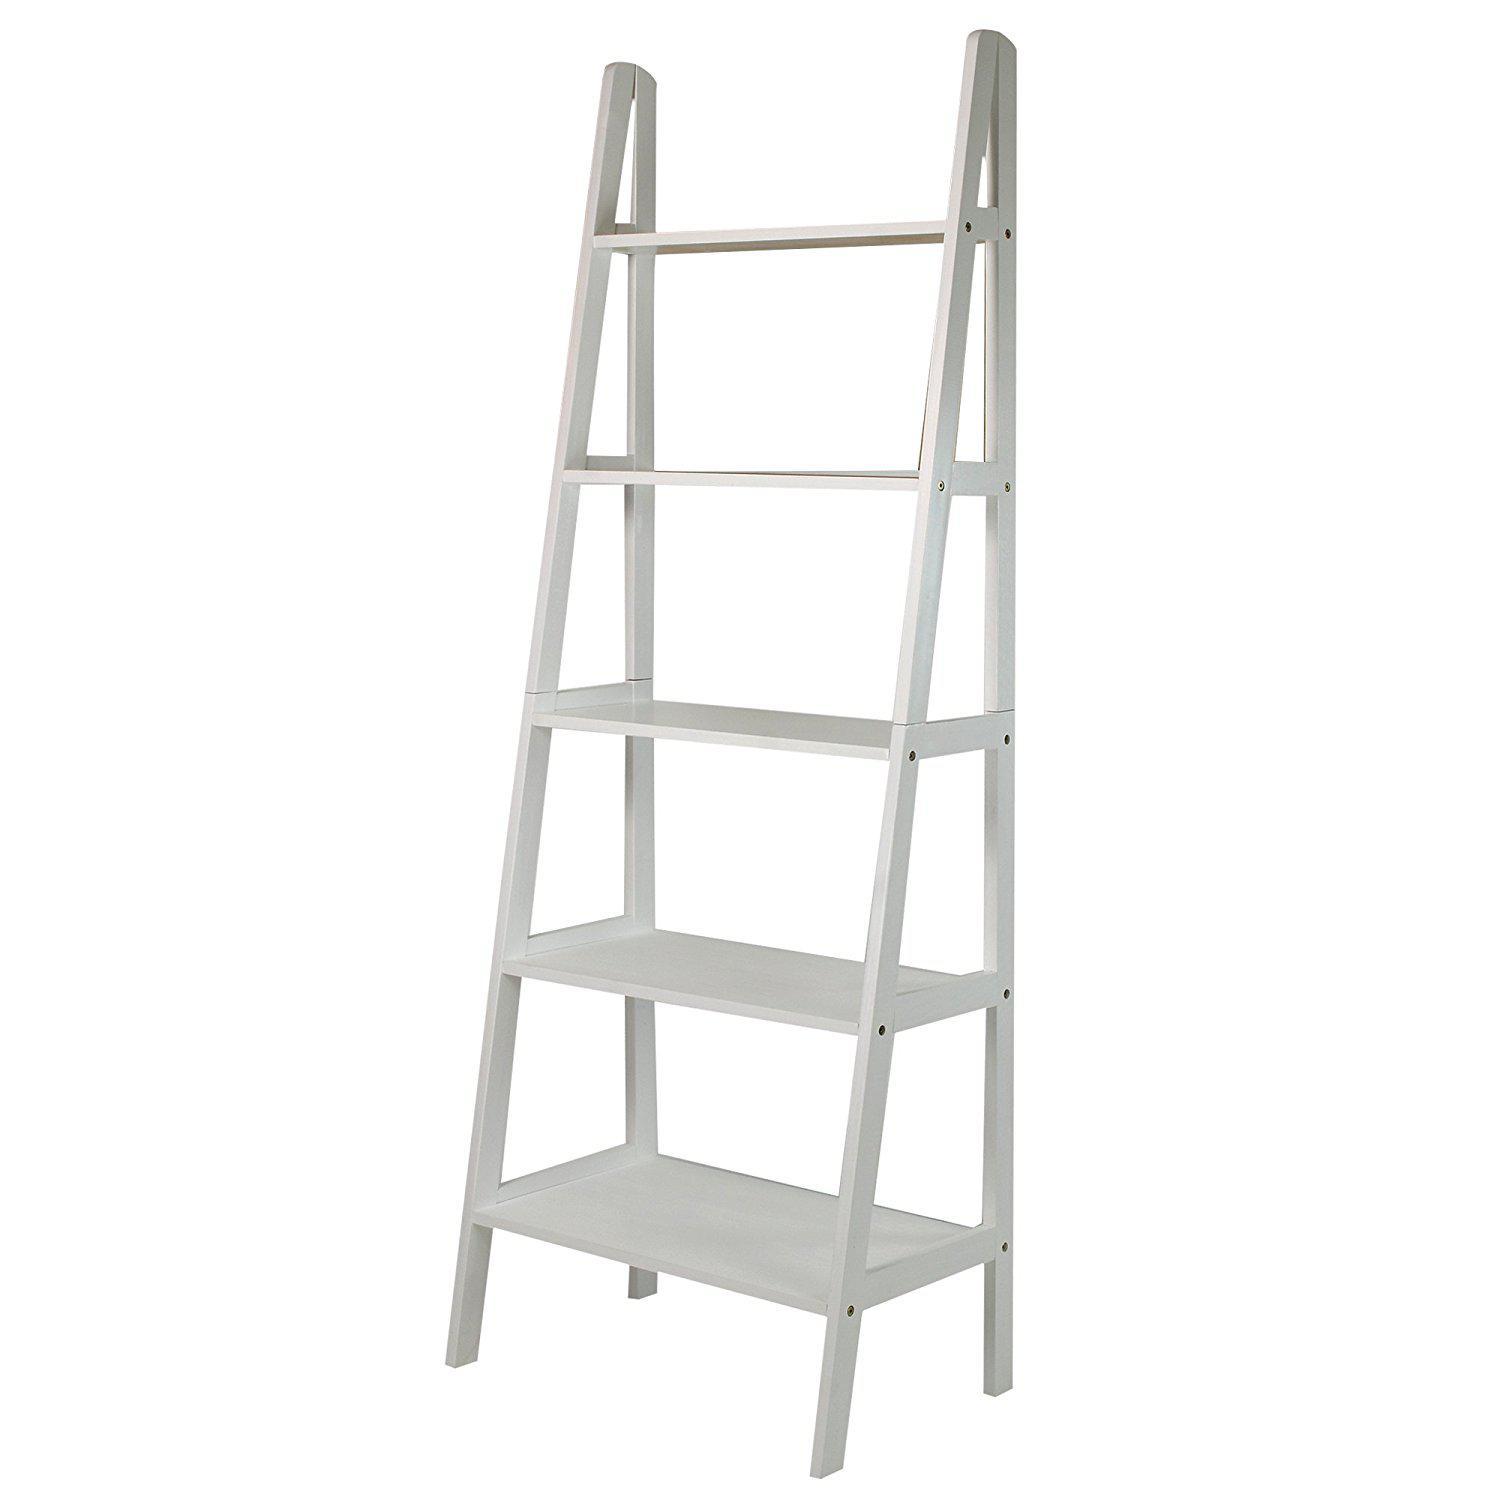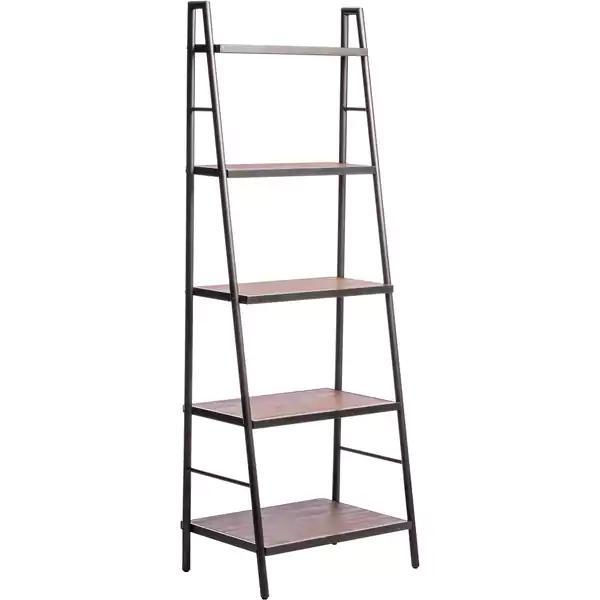The first image is the image on the left, the second image is the image on the right. Assess this claim about the two images: "At least one of the bookshelves has four legs in the shape of an inverted v.". Correct or not? Answer yes or no. Yes. The first image is the image on the left, the second image is the image on the right. Examine the images to the left and right. Is the description "At least one shelf has items on it." accurate? Answer yes or no. No. 